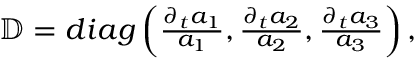Convert formula to latex. <formula><loc_0><loc_0><loc_500><loc_500>\begin{array} { r } { \mathbb { D } = d i a g \left ( \frac { \partial _ { t } a _ { 1 } } { a _ { 1 } } , \frac { \partial _ { t } a _ { 2 } } { a _ { 2 } } , \frac { \partial _ { t } a _ { 3 } } { a _ { 3 } } \right ) , } \end{array}</formula> 